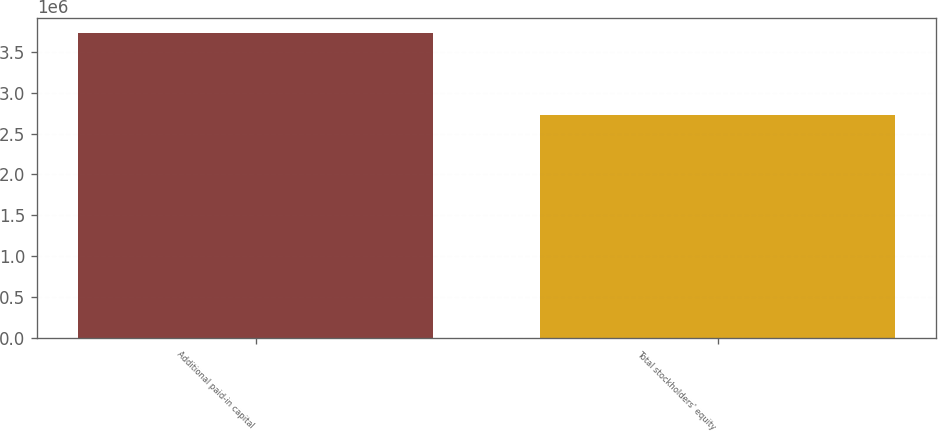Convert chart. <chart><loc_0><loc_0><loc_500><loc_500><bar_chart><fcel>Additional paid-in capital<fcel>Total stockholders' equity<nl><fcel>3.72982e+06<fcel>2.72141e+06<nl></chart> 